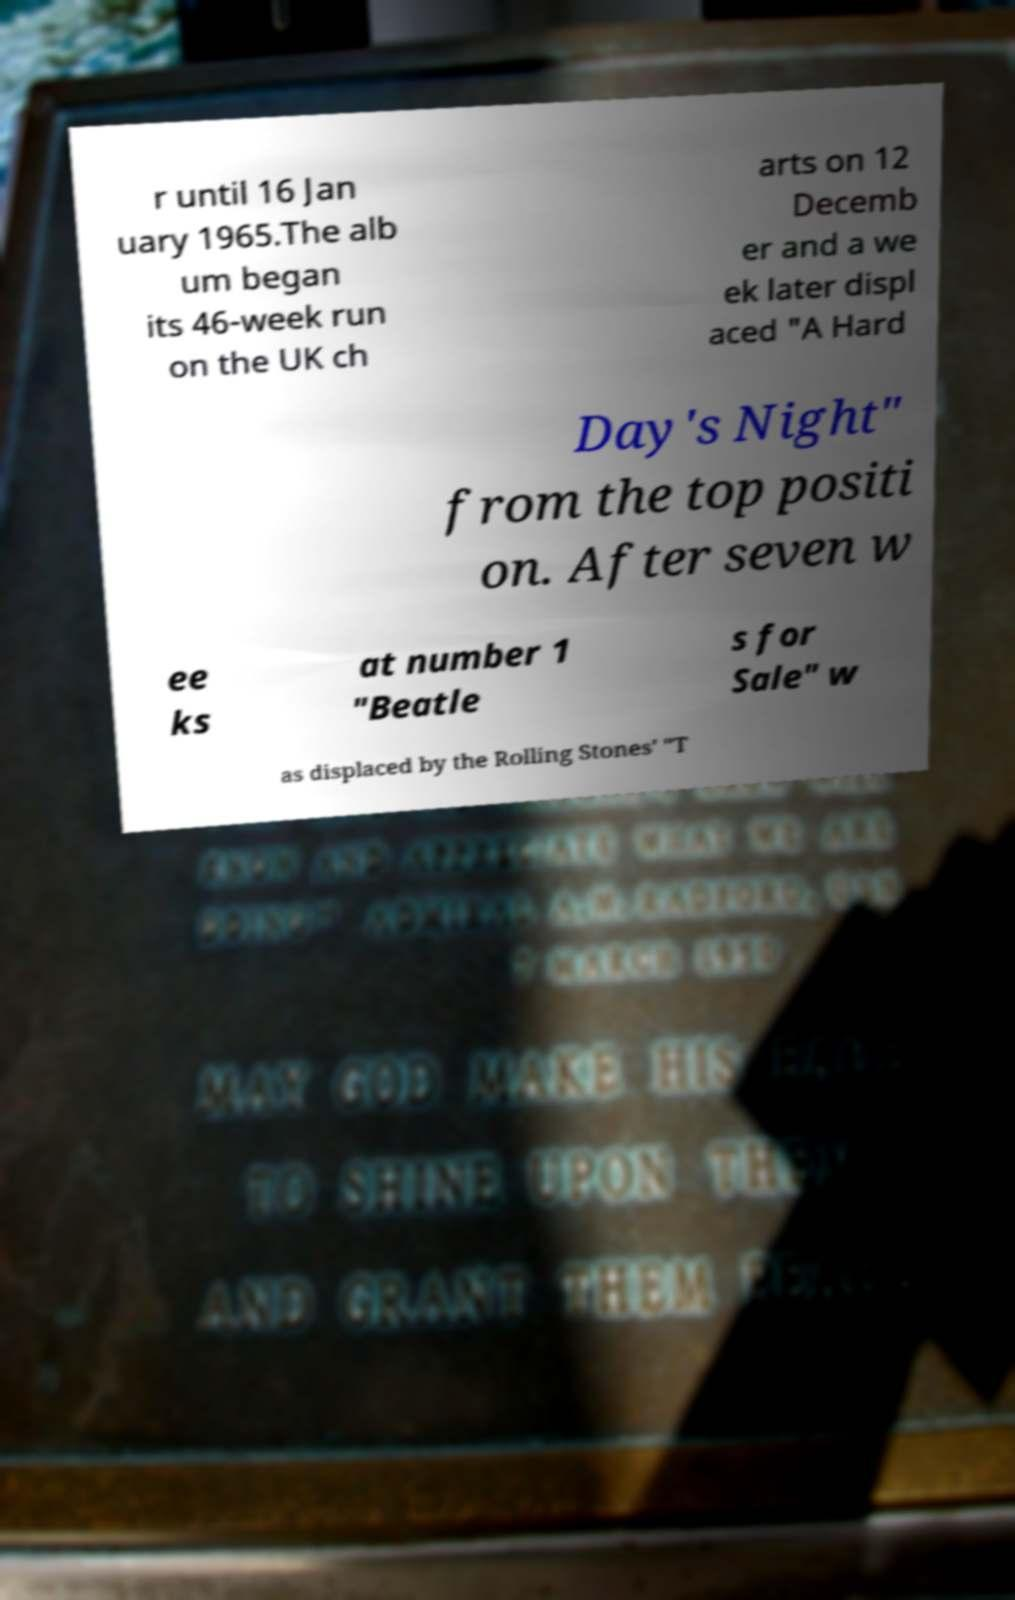Please read and relay the text visible in this image. What does it say? r until 16 Jan uary 1965.The alb um began its 46-week run on the UK ch arts on 12 Decemb er and a we ek later displ aced "A Hard Day's Night" from the top positi on. After seven w ee ks at number 1 "Beatle s for Sale" w as displaced by the Rolling Stones' "T 